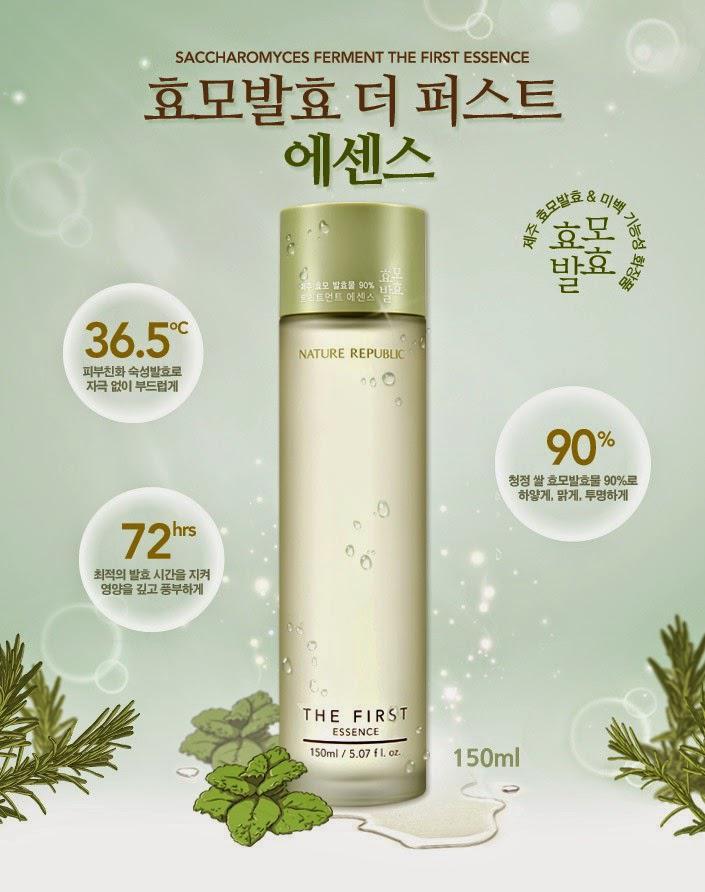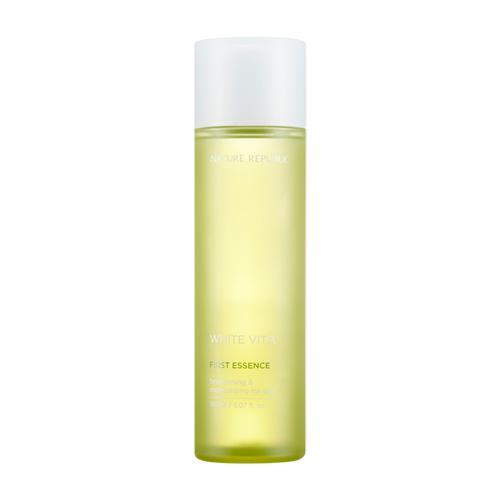The first image is the image on the left, the second image is the image on the right. For the images shown, is this caption "The left image contains one fragrance bottle standing alone, and the right image contains a fragrance bottle to the right of its box." true? Answer yes or no. No. The first image is the image on the left, the second image is the image on the right. Examine the images to the left and right. Is the description "At least one bottle in the image on the left has a silver cap." accurate? Answer yes or no. No. 